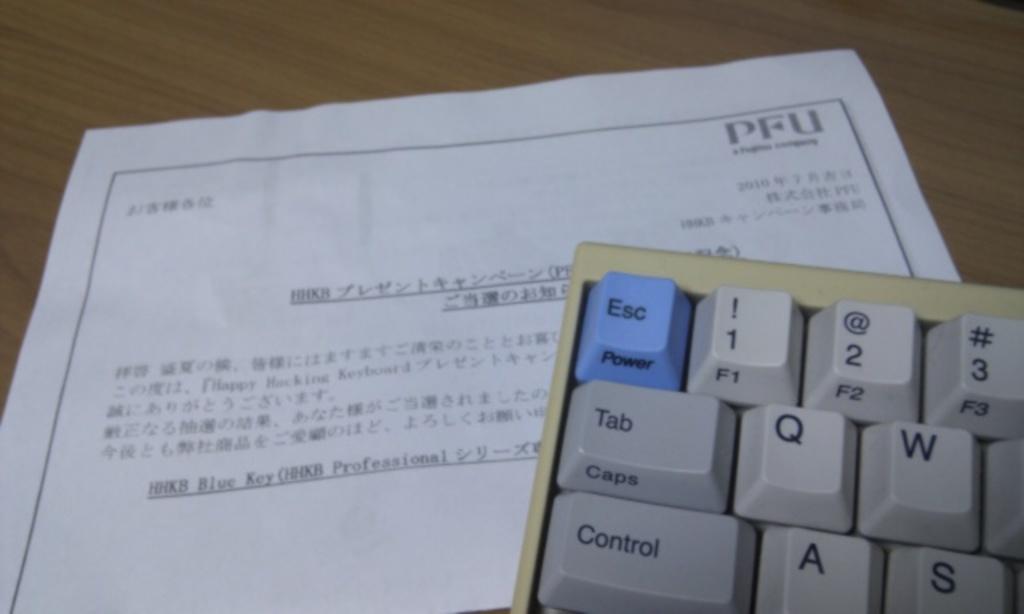Which button should i press if i want to exit?
Provide a succinct answer. Esc. What numbers are shown on the keyboard?
Offer a terse response. 123. 